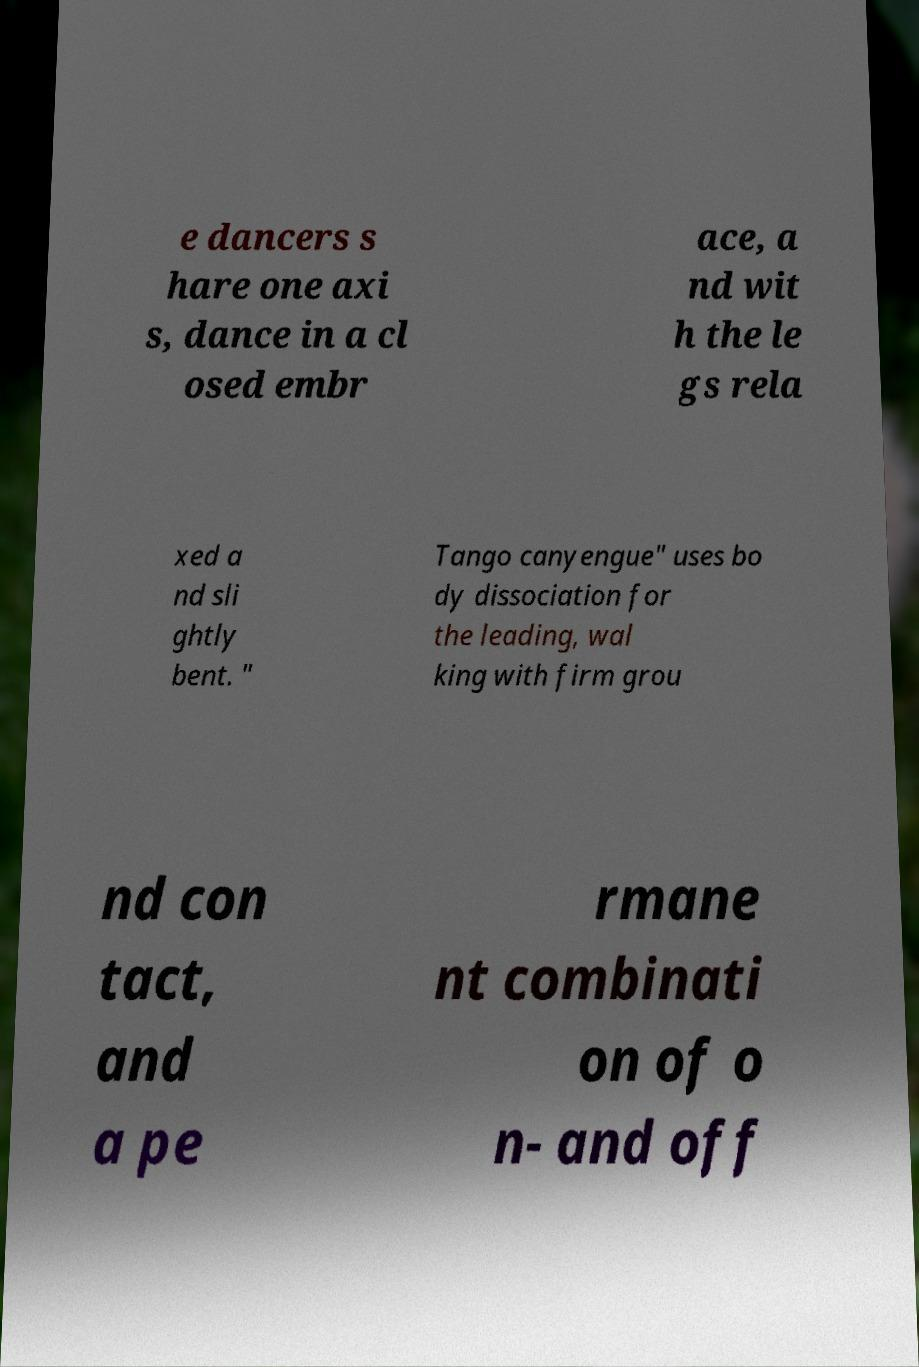Could you assist in decoding the text presented in this image and type it out clearly? e dancers s hare one axi s, dance in a cl osed embr ace, a nd wit h the le gs rela xed a nd sli ghtly bent. " Tango canyengue" uses bo dy dissociation for the leading, wal king with firm grou nd con tact, and a pe rmane nt combinati on of o n- and off 